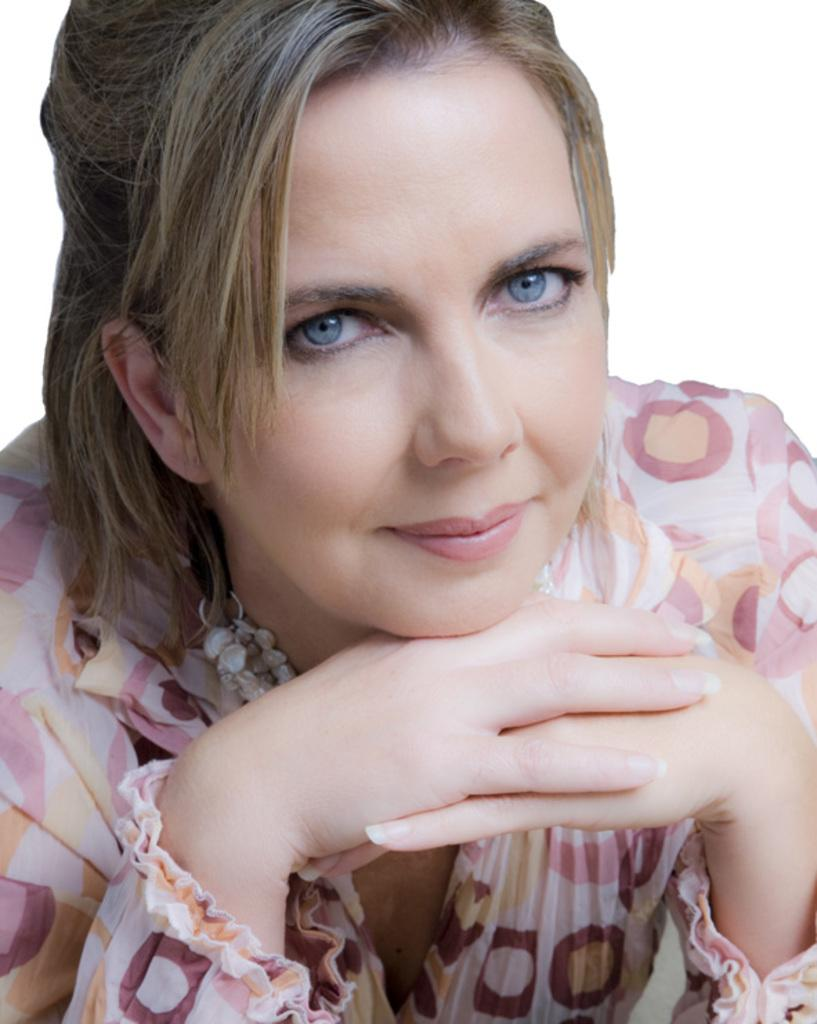Who is present in the image? There is a woman in the image. What is the woman wearing? The woman is wearing a pink and yellow color dress. What is the color of the background in the image? The background of the image is white. What type of wine is the woman holding in the image? There is no wine present in the image; the woman is not holding any wine. 